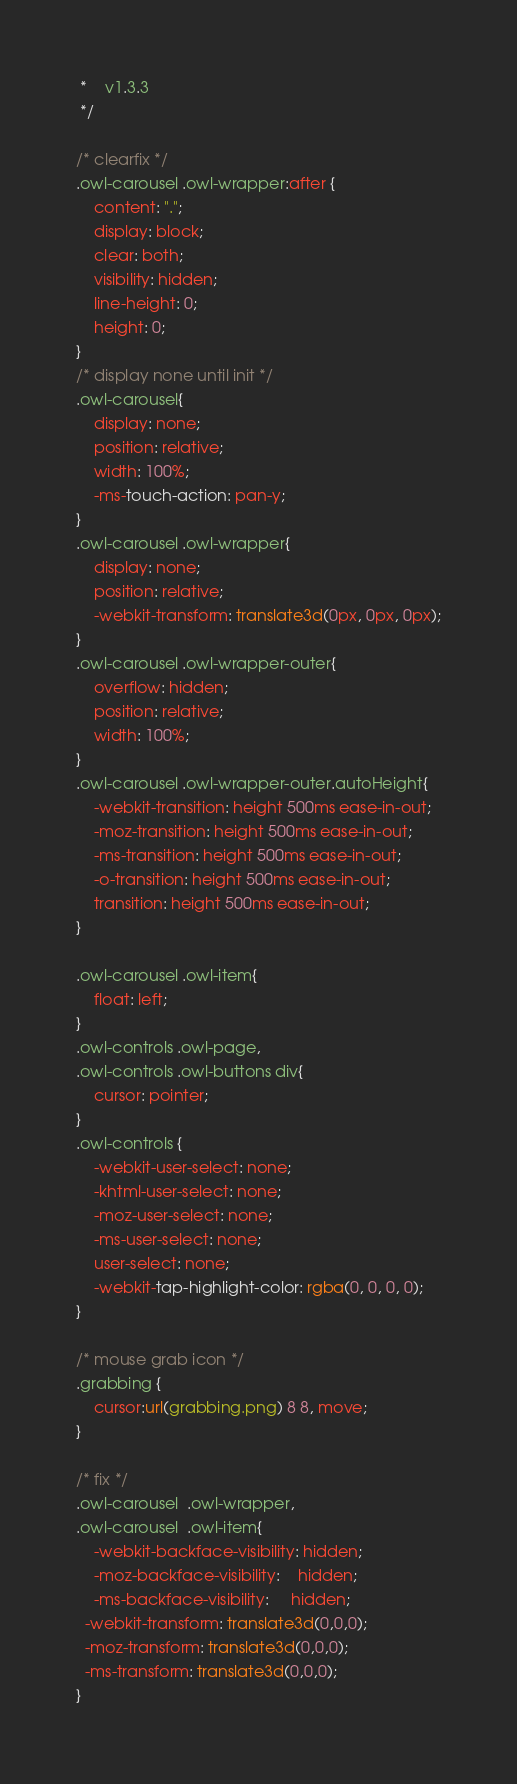Convert code to text. <code><loc_0><loc_0><loc_500><loc_500><_CSS_> *	v1.3.3
 */

/* clearfix */
.owl-carousel .owl-wrapper:after {
	content: ".";
	display: block;
	clear: both;
	visibility: hidden;
	line-height: 0;
	height: 0;
}
/* display none until init */
.owl-carousel{
	display: none;
	position: relative;
	width: 100%;
	-ms-touch-action: pan-y;
}
.owl-carousel .owl-wrapper{
	display: none;
	position: relative;
	-webkit-transform: translate3d(0px, 0px, 0px);
}
.owl-carousel .owl-wrapper-outer{
	overflow: hidden;
	position: relative;
	width: 100%;
}
.owl-carousel .owl-wrapper-outer.autoHeight{
	-webkit-transition: height 500ms ease-in-out;
	-moz-transition: height 500ms ease-in-out;
	-ms-transition: height 500ms ease-in-out;
	-o-transition: height 500ms ease-in-out;
	transition: height 500ms ease-in-out;
}
	
.owl-carousel .owl-item{
	float: left;
}
.owl-controls .owl-page,
.owl-controls .owl-buttons div{
	cursor: pointer;
}
.owl-controls {
	-webkit-user-select: none;
	-khtml-user-select: none;
	-moz-user-select: none;
	-ms-user-select: none;
	user-select: none;
	-webkit-tap-highlight-color: rgba(0, 0, 0, 0);
}

/* mouse grab icon */
.grabbing { 
    cursor:url(grabbing.png) 8 8, move;
}

/* fix */
.owl-carousel  .owl-wrapper,
.owl-carousel  .owl-item{
	-webkit-backface-visibility: hidden;
	-moz-backface-visibility:    hidden;
	-ms-backface-visibility:     hidden;
  -webkit-transform: translate3d(0,0,0);
  -moz-transform: translate3d(0,0,0);
  -ms-transform: translate3d(0,0,0);
}

</code> 